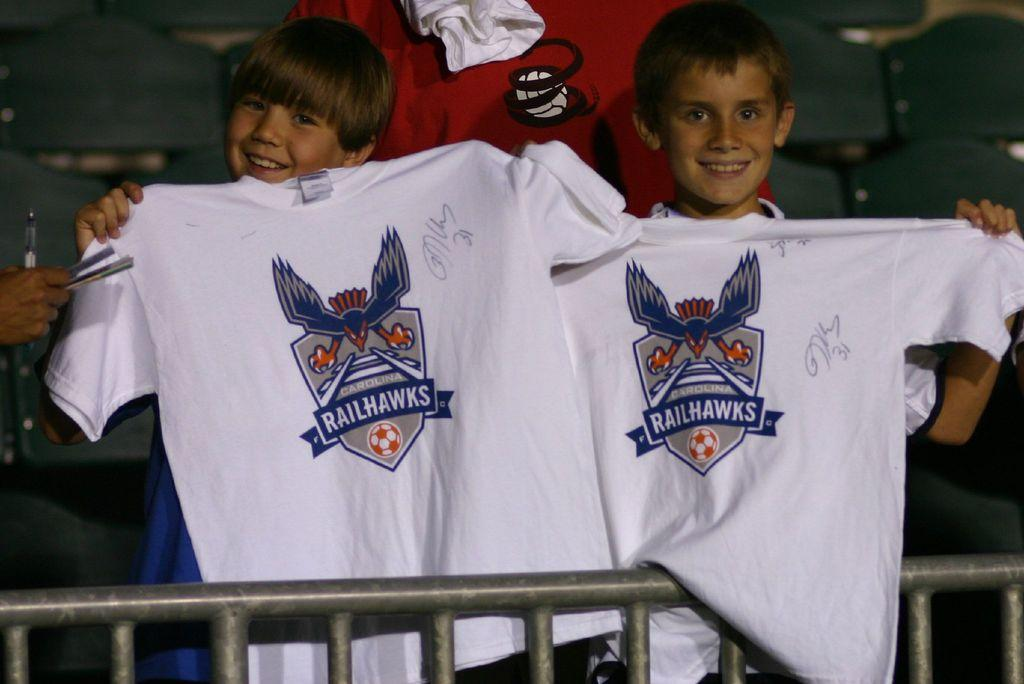<image>
Give a short and clear explanation of the subsequent image. 2 boys holding up white shirts that says RailHawks on them. 